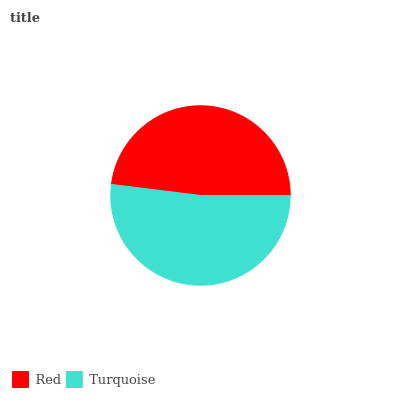Is Red the minimum?
Answer yes or no. Yes. Is Turquoise the maximum?
Answer yes or no. Yes. Is Turquoise the minimum?
Answer yes or no. No. Is Turquoise greater than Red?
Answer yes or no. Yes. Is Red less than Turquoise?
Answer yes or no. Yes. Is Red greater than Turquoise?
Answer yes or no. No. Is Turquoise less than Red?
Answer yes or no. No. Is Turquoise the high median?
Answer yes or no. Yes. Is Red the low median?
Answer yes or no. Yes. Is Red the high median?
Answer yes or no. No. Is Turquoise the low median?
Answer yes or no. No. 